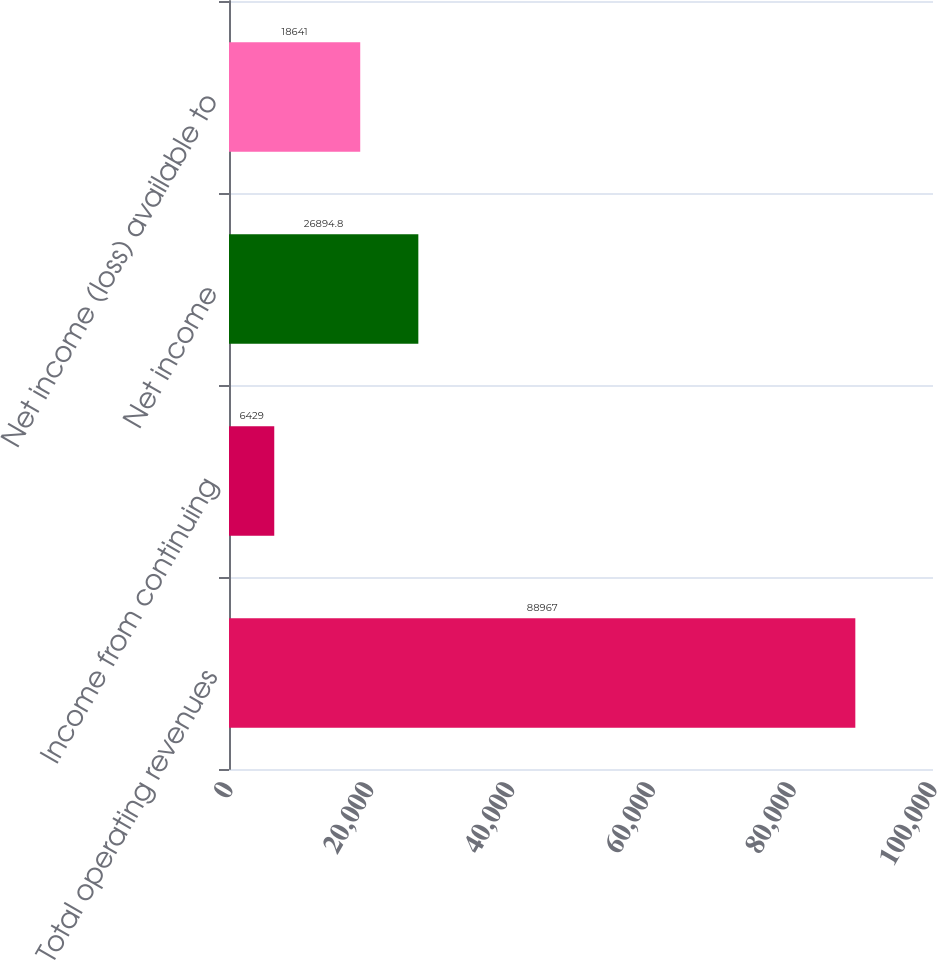Convert chart to OTSL. <chart><loc_0><loc_0><loc_500><loc_500><bar_chart><fcel>Total operating revenues<fcel>Income from continuing<fcel>Net income<fcel>Net income (loss) available to<nl><fcel>88967<fcel>6429<fcel>26894.8<fcel>18641<nl></chart> 